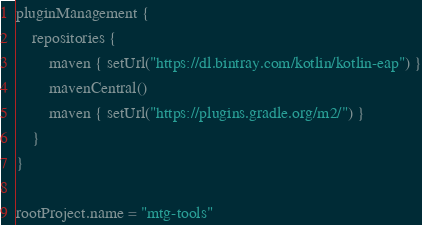<code> <loc_0><loc_0><loc_500><loc_500><_Kotlin_>pluginManagement {
    repositories {
        maven { setUrl("https://dl.bintray.com/kotlin/kotlin-eap") }
        mavenCentral()
        maven { setUrl("https://plugins.gradle.org/m2/") }
    }
}

rootProject.name = "mtg-tools"
</code> 